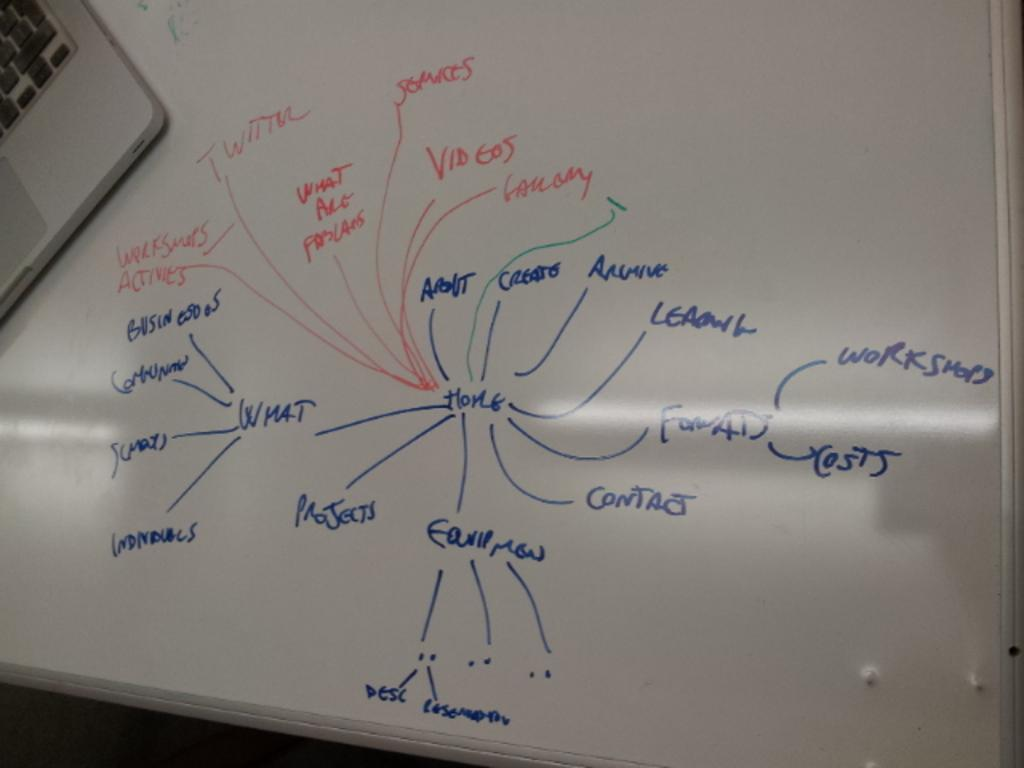<image>
Present a compact description of the photo's key features. A webbed map on a whiteboard linking different terms to home. 